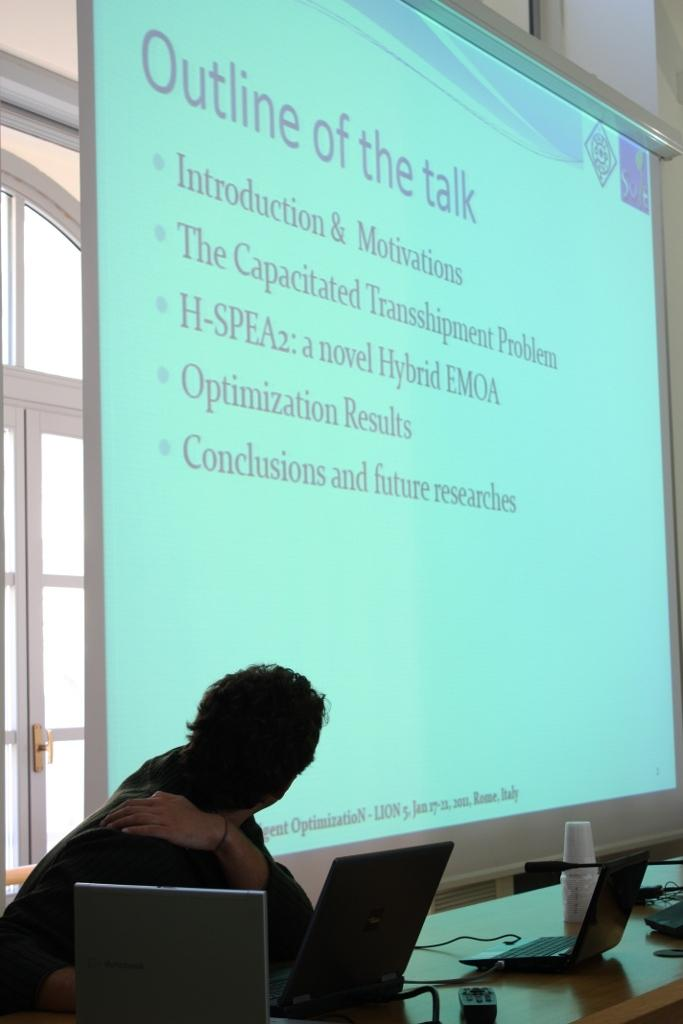<image>
Relay a brief, clear account of the picture shown. A class room with a viewing screen that has a slide titled Outline of the talk. 